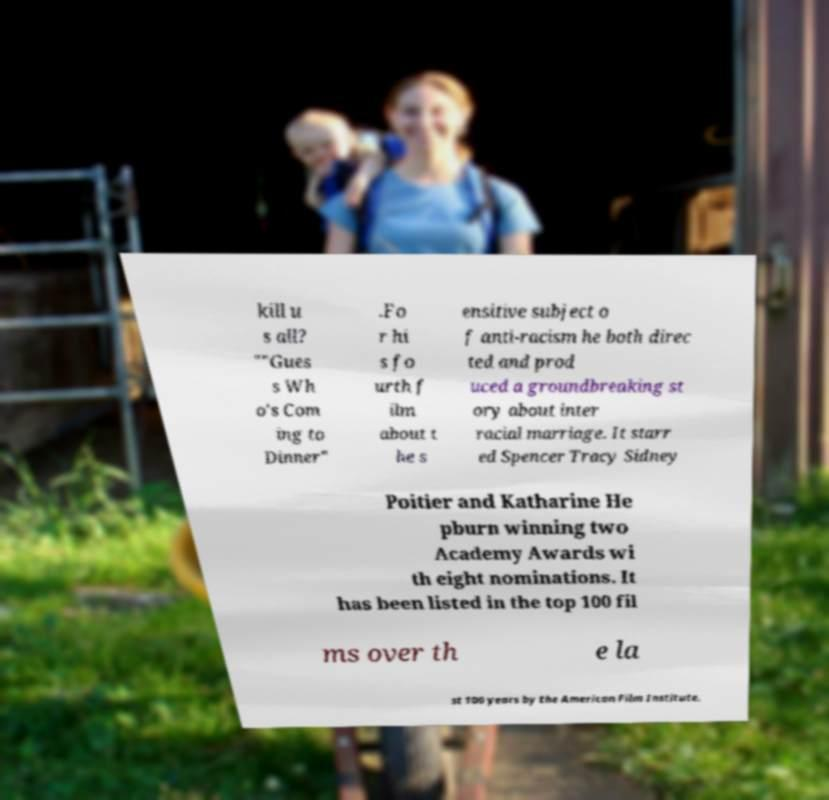For documentation purposes, I need the text within this image transcribed. Could you provide that? kill u s all? ""Gues s Wh o's Com ing to Dinner" .Fo r hi s fo urth f ilm about t he s ensitive subject o f anti-racism he both direc ted and prod uced a groundbreaking st ory about inter racial marriage. It starr ed Spencer Tracy Sidney Poitier and Katharine He pburn winning two Academy Awards wi th eight nominations. It has been listed in the top 100 fil ms over th e la st 100 years by the American Film Institute. 